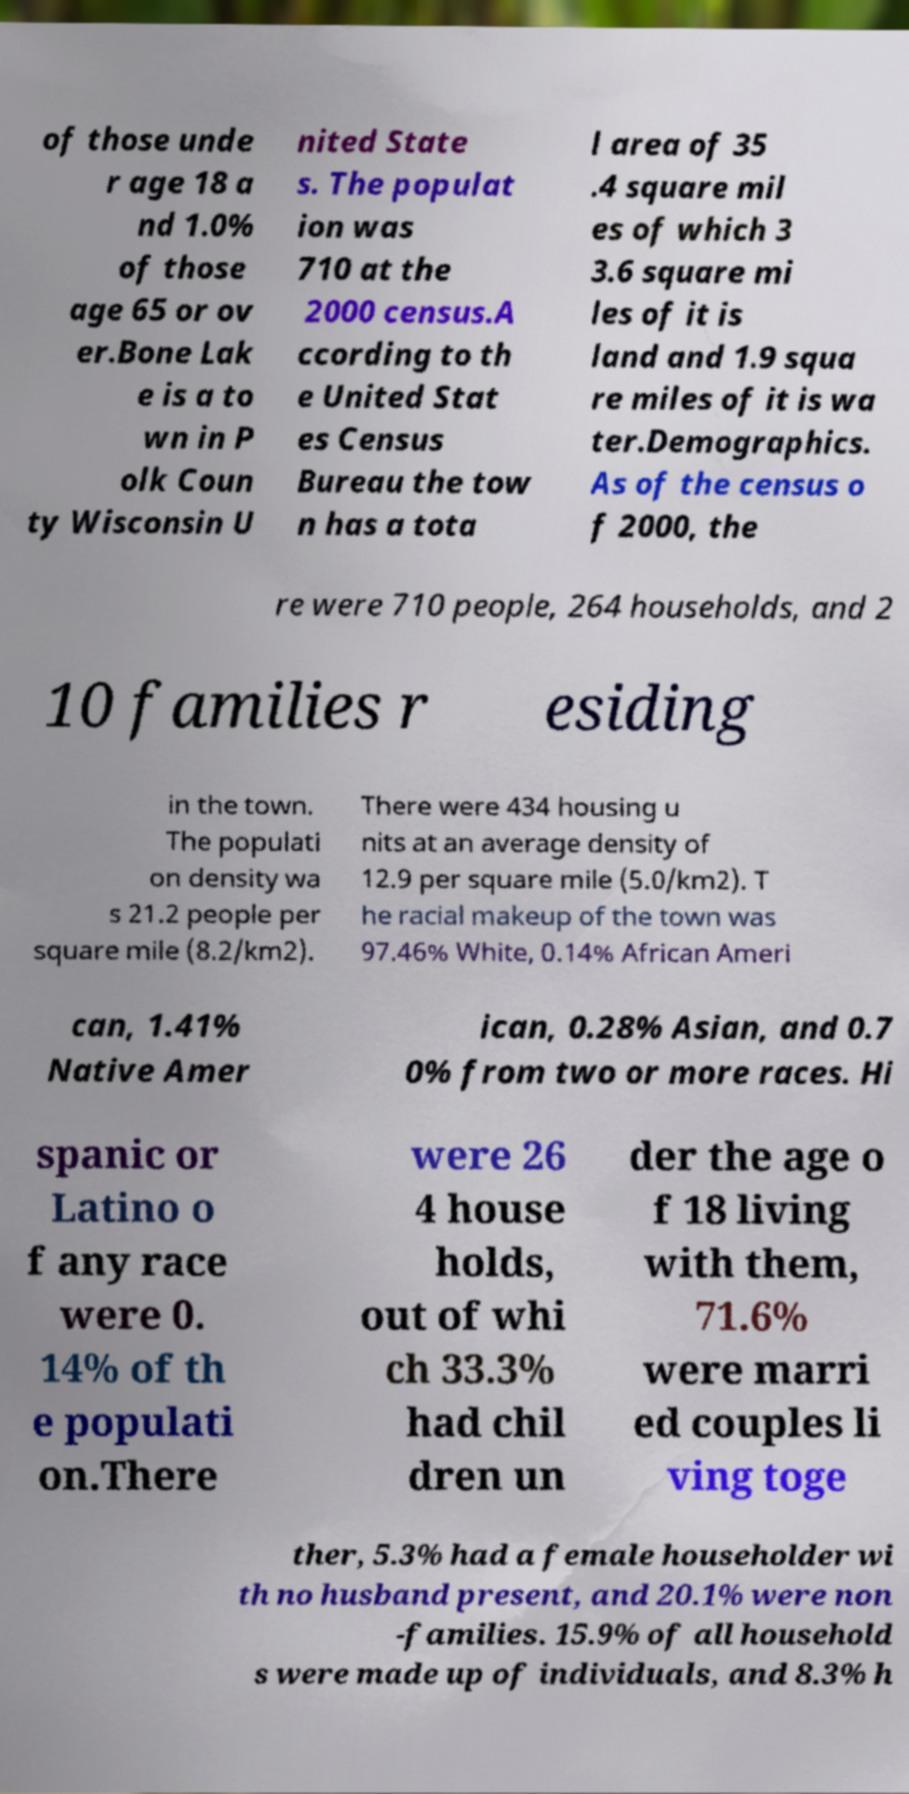Can you accurately transcribe the text from the provided image for me? of those unde r age 18 a nd 1.0% of those age 65 or ov er.Bone Lak e is a to wn in P olk Coun ty Wisconsin U nited State s. The populat ion was 710 at the 2000 census.A ccording to th e United Stat es Census Bureau the tow n has a tota l area of 35 .4 square mil es of which 3 3.6 square mi les of it is land and 1.9 squa re miles of it is wa ter.Demographics. As of the census o f 2000, the re were 710 people, 264 households, and 2 10 families r esiding in the town. The populati on density wa s 21.2 people per square mile (8.2/km2). There were 434 housing u nits at an average density of 12.9 per square mile (5.0/km2). T he racial makeup of the town was 97.46% White, 0.14% African Ameri can, 1.41% Native Amer ican, 0.28% Asian, and 0.7 0% from two or more races. Hi spanic or Latino o f any race were 0. 14% of th e populati on.There were 26 4 house holds, out of whi ch 33.3% had chil dren un der the age o f 18 living with them, 71.6% were marri ed couples li ving toge ther, 5.3% had a female householder wi th no husband present, and 20.1% were non -families. 15.9% of all household s were made up of individuals, and 8.3% h 